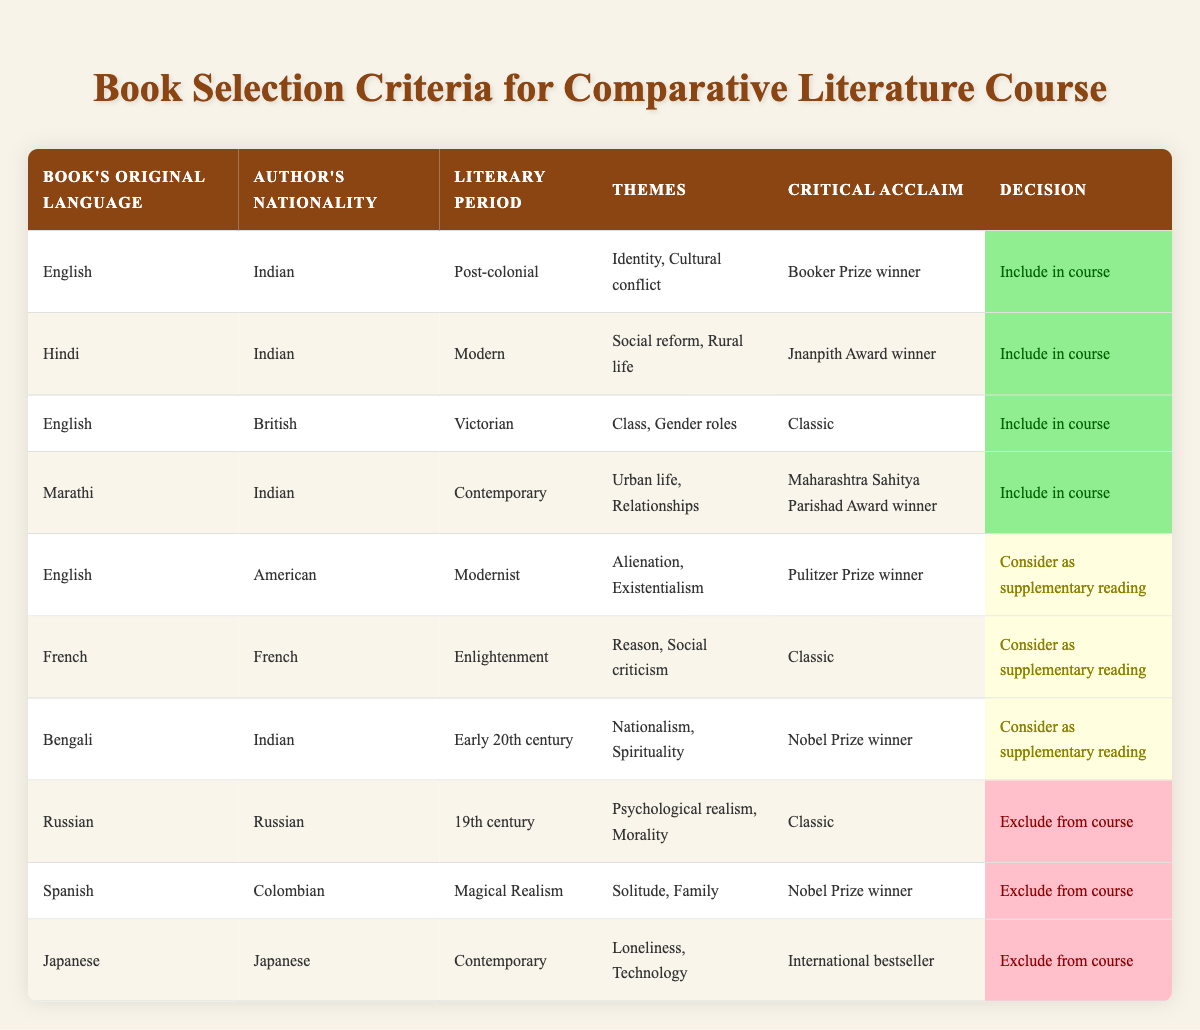What languages are included in the course? The table shows that books in English and Hindi are included, as they both have specified conditions leading to "Include in course" actions.
Answer: English, Hindi How many authors from India are considered for supplementary reading? The table does not have any entries that meet the criteria for "Consider as supplementary reading" with the author's nationality being Indian. Therefore, the count is zero.
Answer: 0 Is there any book excluded from the course written in Spanish? The table clearly indicates that there is a book in Spanish that is excluded, specifically the one labeled as "Excluded from course" under the Spanish conditions.
Answer: Yes What is the critical acclaim of the Japanese book that has been excluded? The table shows that the Japanese book is labeled as an "International bestseller" but is still excluded from the course, indicating its acclaim.
Answer: International bestseller How many books are included in the course based on the themes of identity or cultural conflict? Upon reviewing the books in the table, only one book addresses the themes of identity or cultural conflict, which is from Indian authorship and English language. Thus, the count is one.
Answer: 1 Are there any authors who received both the Nobel Prize and are included in the course? Reviewing the table entries, the only Nobel Prize winner mentioned is Bengali but no action tags “Include in course,” thus no author from this category is included.
Answer: No What is the literary period of the book included by the Marathi author? The table specifies the literary period of the Marathi book as "Contemporary," and it is marked for inclusion in the course.
Answer: Contemporary Which themes are associated with the supplementary reading for American authors? The supplementary reading considers themes of alienation and existentialism for the American book, evident from the corresponding row in the table.
Answer: Alienation, Existentialism How many books are excluded due to being classics? The entries for excluded books that are noted as classics are categorized under Russian and Spanish literature, accounting for a total of two entries.
Answer: 2 